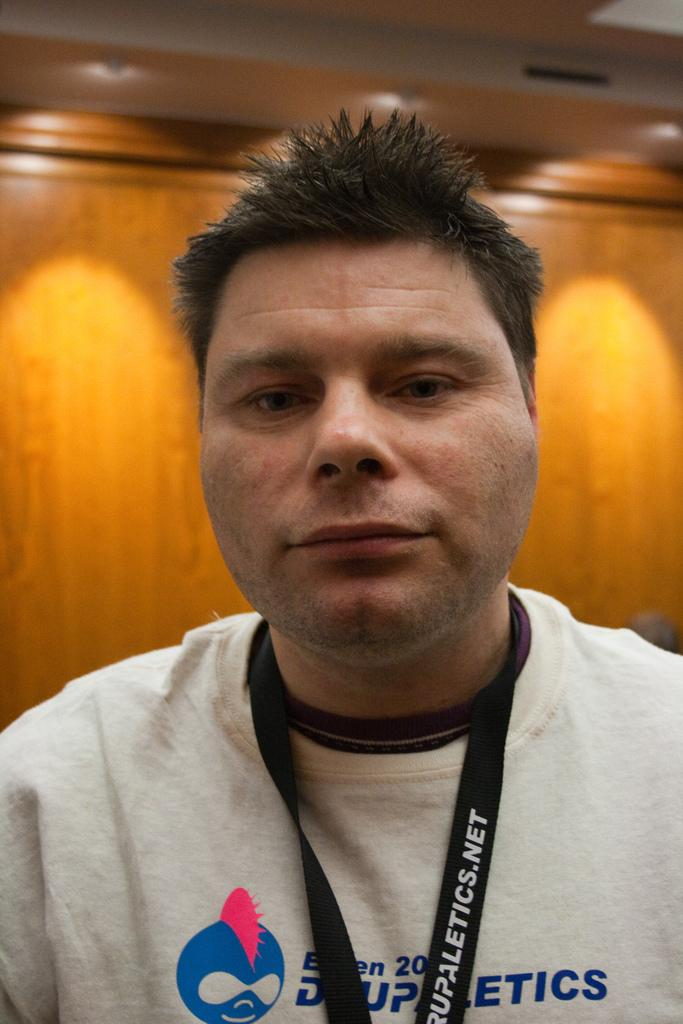<image>
Render a clear and concise summary of the photo. A man is wearing a lanyard with Drupathletics.net written on it. 